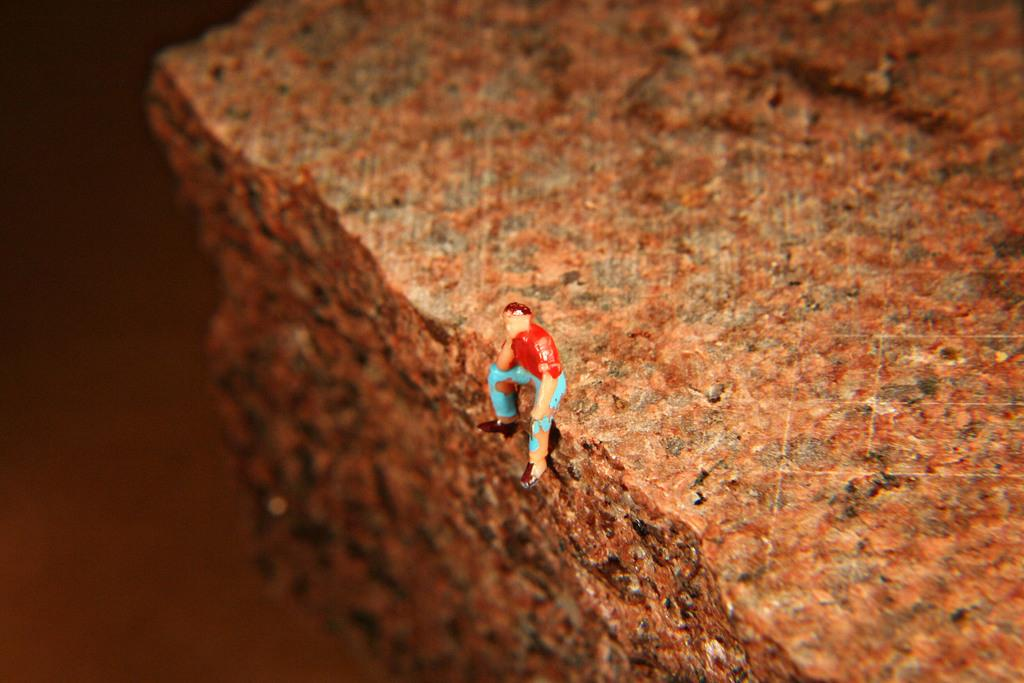What object can be seen in the image? There is a toy in the image. Where is the toy located? The toy is sitting on a rock. Can you describe the quality of the image on the left side? The left side of the image is blurry. What type of quilt is draped over the edge of the toy in the image? There is no quilt present in the image, and the toy is not draped over anything. 